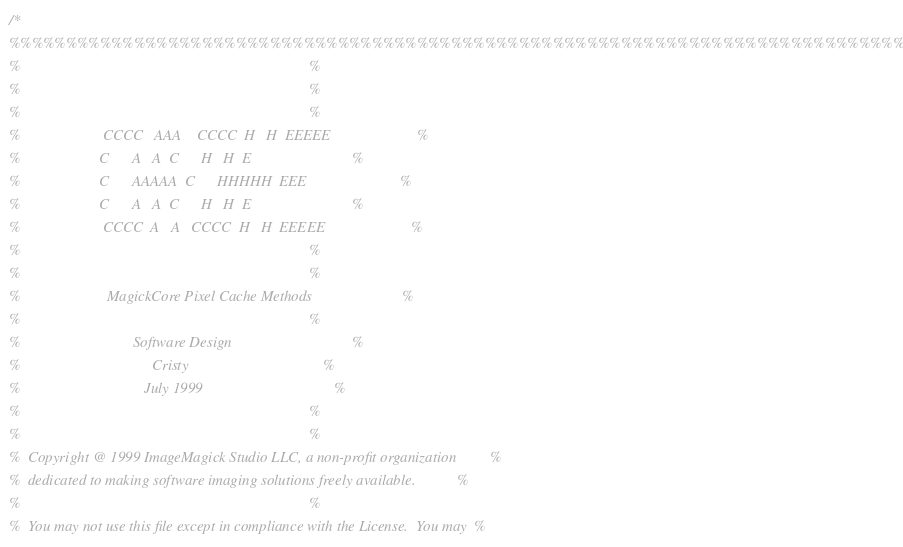<code> <loc_0><loc_0><loc_500><loc_500><_C_>/*
%%%%%%%%%%%%%%%%%%%%%%%%%%%%%%%%%%%%%%%%%%%%%%%%%%%%%%%%%%%%%%%%%%%%%%%%%%%%%%%
%                                                                             %
%                                                                             %
%                                                                             %
%                      CCCC   AAA    CCCC  H   H  EEEEE                       %
%                     C      A   A  C      H   H  E                           %
%                     C      AAAAA  C      HHHHH  EEE                         %
%                     C      A   A  C      H   H  E                           %
%                      CCCC  A   A   CCCC  H   H  EEEEE                       %
%                                                                             %
%                                                                             %
%                       MagickCore Pixel Cache Methods                        %
%                                                                             %
%                              Software Design                                %
%                                   Cristy                                    %
%                                 July 1999                                   %
%                                                                             %
%                                                                             %
%  Copyright @ 1999 ImageMagick Studio LLC, a non-profit organization         %
%  dedicated to making software imaging solutions freely available.           %
%                                                                             %
%  You may not use this file except in compliance with the License.  You may  %</code> 